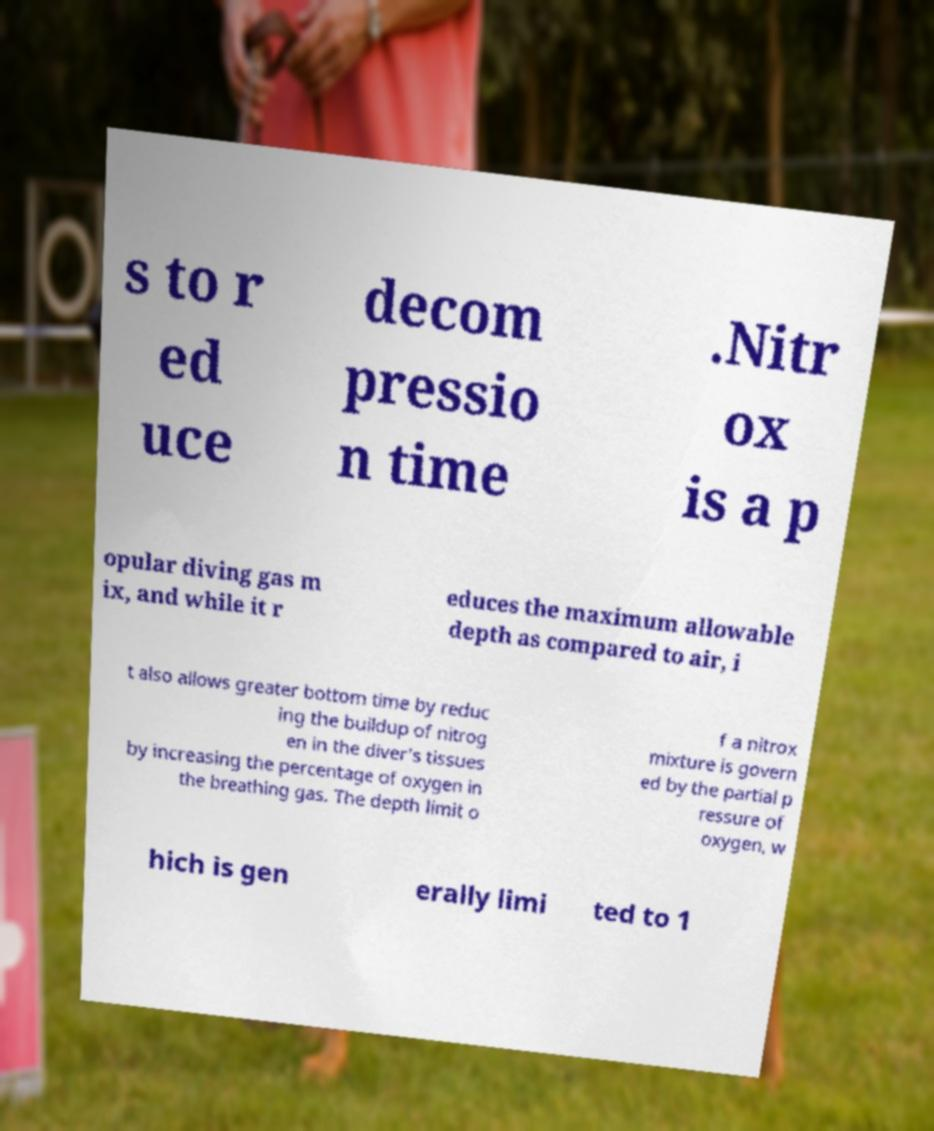What messages or text are displayed in this image? I need them in a readable, typed format. s to r ed uce decom pressio n time .Nitr ox is a p opular diving gas m ix, and while it r educes the maximum allowable depth as compared to air, i t also allows greater bottom time by reduc ing the buildup of nitrog en in the diver's tissues by increasing the percentage of oxygen in the breathing gas. The depth limit o f a nitrox mixture is govern ed by the partial p ressure of oxygen, w hich is gen erally limi ted to 1 